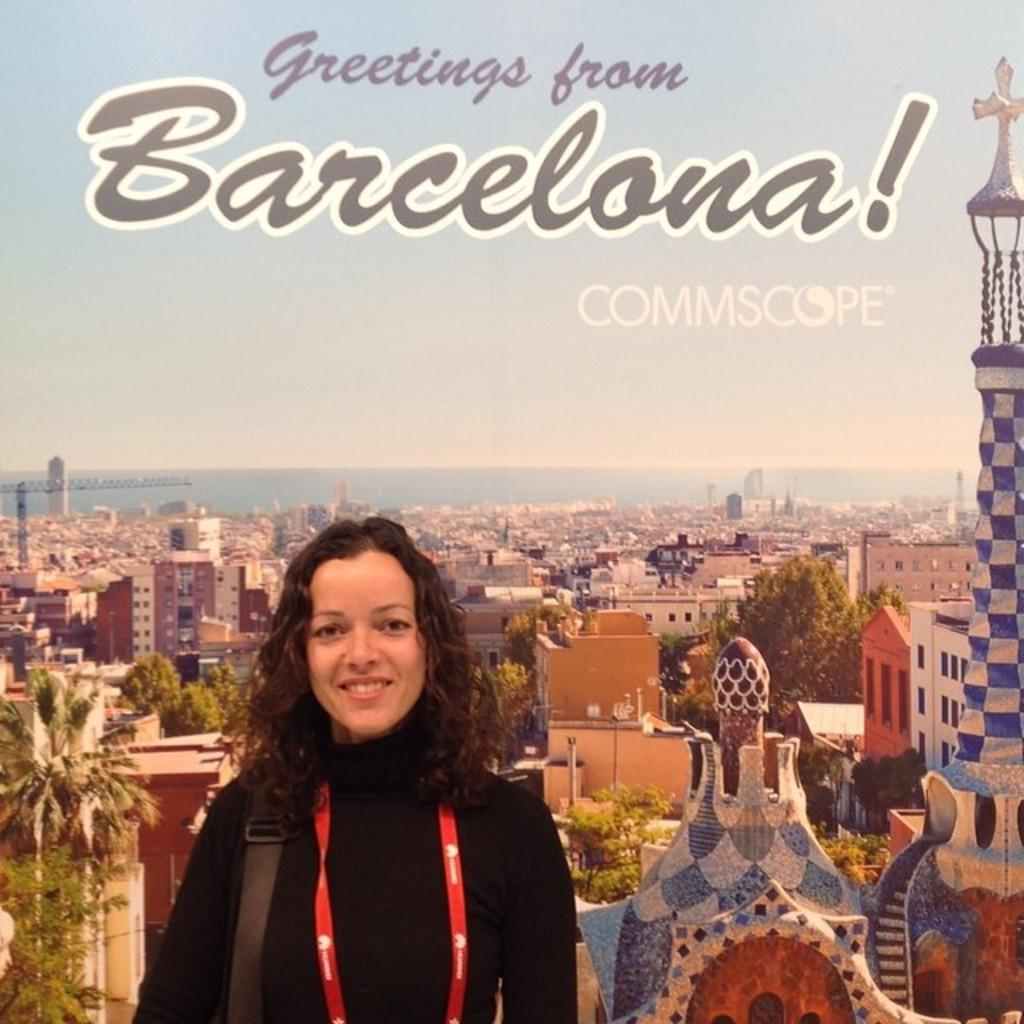Who is present in the image? There is a woman in the image. What can be seen in the background of the image? There are buildings and a water surface visible in the background of the image. What is the size of the tooth in the image? There is no tooth present in the image. 